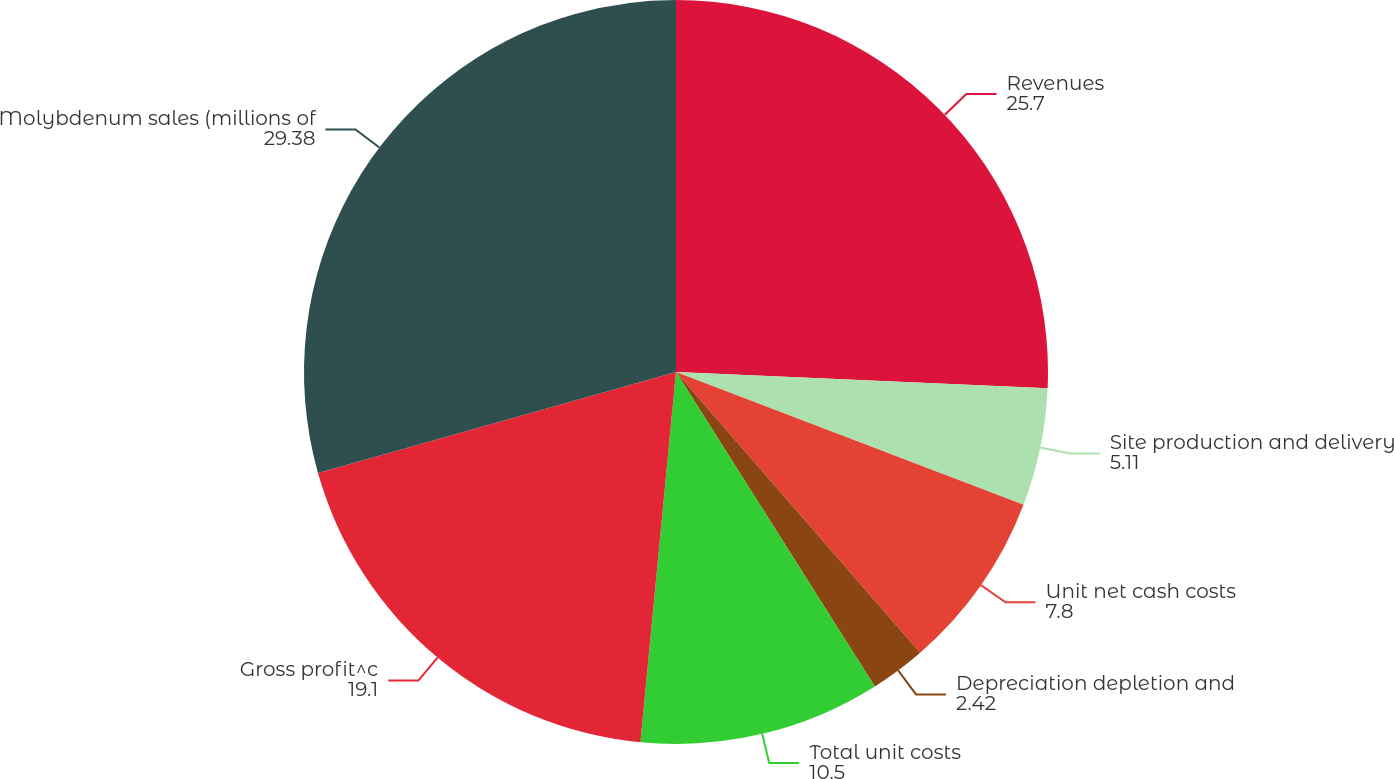<chart> <loc_0><loc_0><loc_500><loc_500><pie_chart><fcel>Revenues<fcel>Site production and delivery<fcel>Unit net cash costs<fcel>Depreciation depletion and<fcel>Total unit costs<fcel>Gross profit^c<fcel>Molybdenum sales (millions of<nl><fcel>25.7%<fcel>5.11%<fcel>7.8%<fcel>2.42%<fcel>10.5%<fcel>19.1%<fcel>29.38%<nl></chart> 